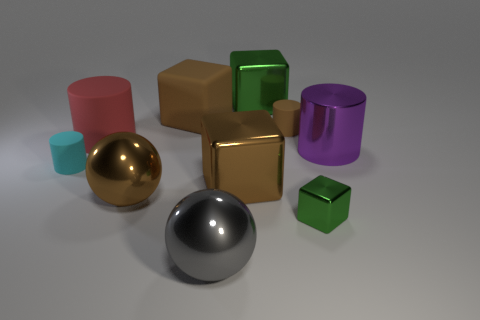The brown thing that is both on the left side of the gray metallic object and behind the large rubber cylinder is made of what material?
Keep it short and to the point. Rubber. What color is the cylinder that is the same size as the red matte object?
Keep it short and to the point. Purple. Is the material of the big red cylinder the same as the tiny thing that is left of the large gray metal sphere?
Your response must be concise. Yes. How many other things are the same size as the brown rubber cylinder?
Offer a terse response. 2. Are there any green metallic objects behind the small matte cylinder that is on the left side of the metallic cube that is behind the purple shiny object?
Offer a very short reply. Yes. What size is the gray metallic object?
Provide a short and direct response. Large. There is a green shiny cube that is behind the big shiny cylinder; what size is it?
Your response must be concise. Large. There is a shiny object left of the gray metallic object; is its size the same as the brown rubber cylinder?
Ensure brevity in your answer.  No. Is there anything else that has the same color as the tiny metal block?
Offer a very short reply. Yes. What is the shape of the tiny shiny thing?
Ensure brevity in your answer.  Cube. 